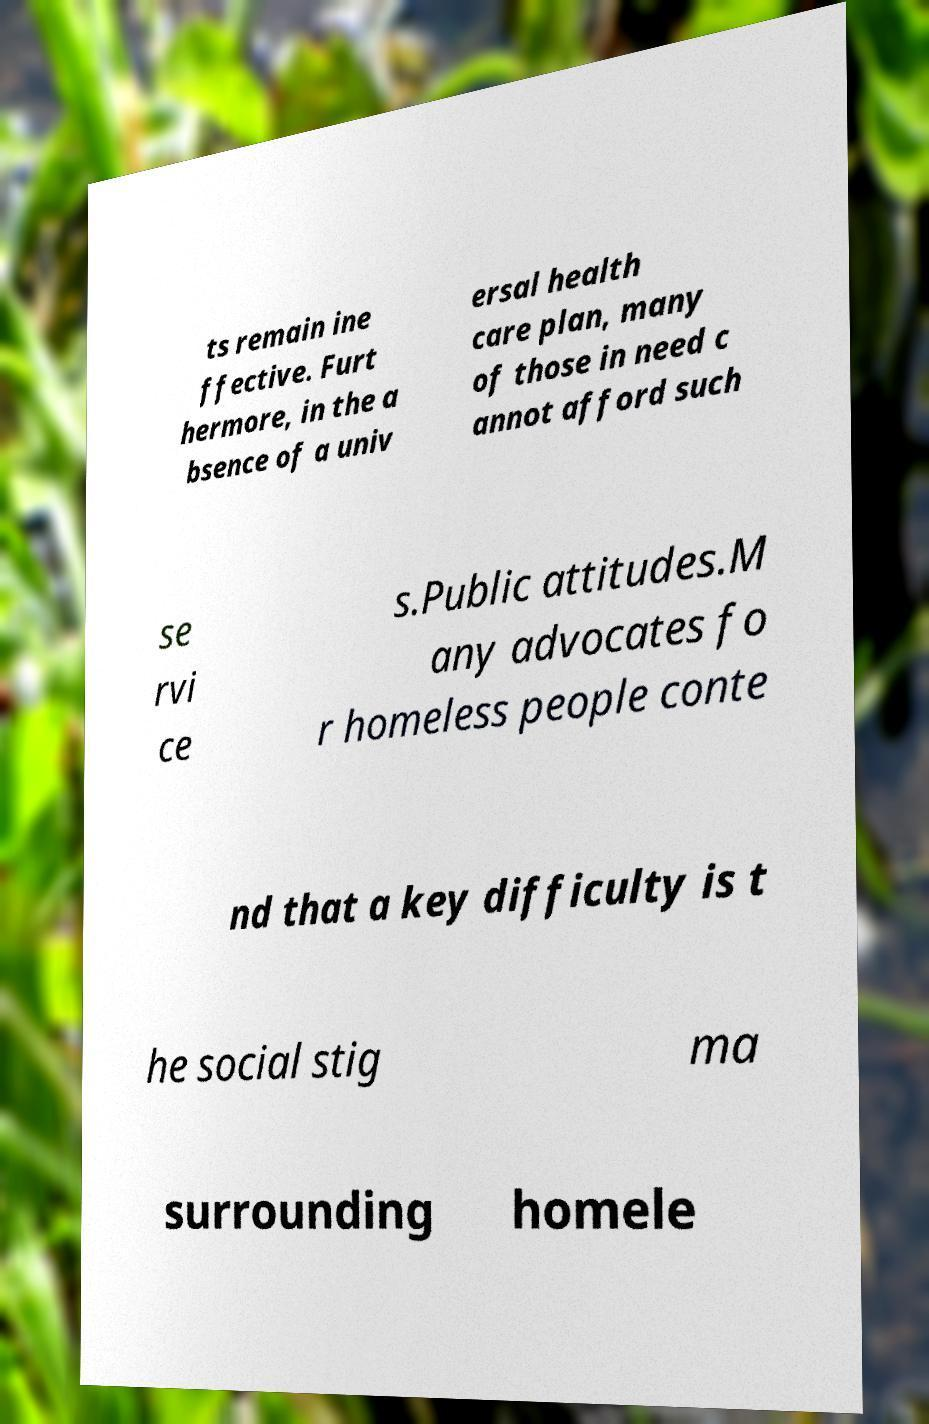Can you read and provide the text displayed in the image?This photo seems to have some interesting text. Can you extract and type it out for me? ts remain ine ffective. Furt hermore, in the a bsence of a univ ersal health care plan, many of those in need c annot afford such se rvi ce s.Public attitudes.M any advocates fo r homeless people conte nd that a key difficulty is t he social stig ma surrounding homele 